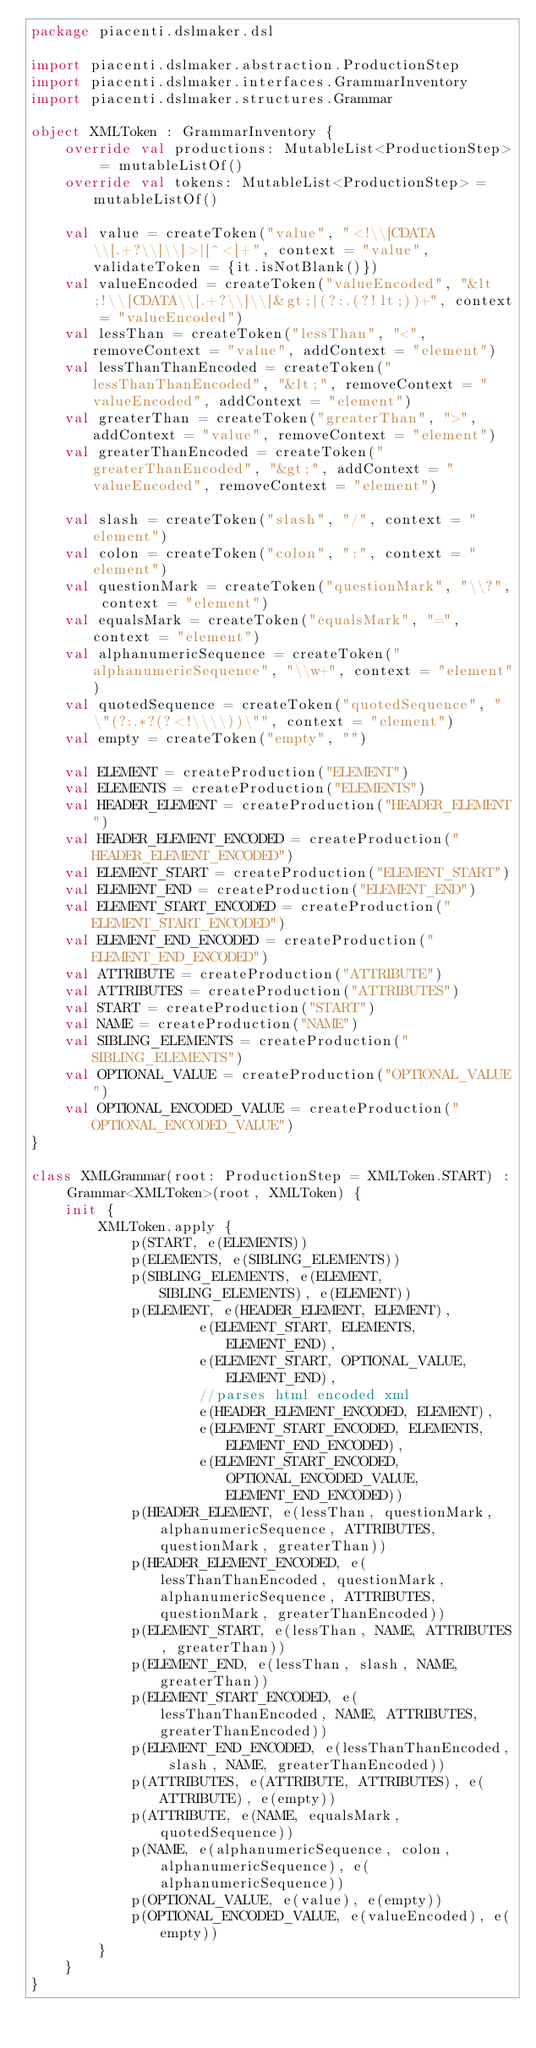Convert code to text. <code><loc_0><loc_0><loc_500><loc_500><_Kotlin_>package piacenti.dslmaker.dsl

import piacenti.dslmaker.abstraction.ProductionStep
import piacenti.dslmaker.interfaces.GrammarInventory
import piacenti.dslmaker.structures.Grammar

object XMLToken : GrammarInventory {
    override val productions: MutableList<ProductionStep> = mutableListOf()
    override val tokens: MutableList<ProductionStep> = mutableListOf()

    val value = createToken("value", "<!\\[CDATA\\[.+?\\]\\]>|[^<]+", context = "value", validateToken = {it.isNotBlank()})
    val valueEncoded = createToken("valueEncoded", "&lt;!\\[CDATA\\[.+?\\]\\]&gt;|(?:.(?!lt;))+", context = "valueEncoded")
    val lessThan = createToken("lessThan", "<", removeContext = "value", addContext = "element")
    val lessThanThanEncoded = createToken("lessThanThanEncoded", "&lt;", removeContext = "valueEncoded", addContext = "element")
    val greaterThan = createToken("greaterThan", ">", addContext = "value", removeContext = "element")
    val greaterThanEncoded = createToken("greaterThanEncoded", "&gt;", addContext = "valueEncoded", removeContext = "element")

    val slash = createToken("slash", "/", context = "element")
    val colon = createToken("colon", ":", context = "element")
    val questionMark = createToken("questionMark", "\\?", context = "element")
    val equalsMark = createToken("equalsMark", "=", context = "element")
    val alphanumericSequence = createToken("alphanumericSequence", "\\w+", context = "element")
    val quotedSequence = createToken("quotedSequence", "\"(?:.*?(?<!\\\\))\"", context = "element")
    val empty = createToken("empty", "")

    val ELEMENT = createProduction("ELEMENT")
    val ELEMENTS = createProduction("ELEMENTS")
    val HEADER_ELEMENT = createProduction("HEADER_ELEMENT")
    val HEADER_ELEMENT_ENCODED = createProduction("HEADER_ELEMENT_ENCODED")
    val ELEMENT_START = createProduction("ELEMENT_START")
    val ELEMENT_END = createProduction("ELEMENT_END")
    val ELEMENT_START_ENCODED = createProduction("ELEMENT_START_ENCODED")
    val ELEMENT_END_ENCODED = createProduction("ELEMENT_END_ENCODED")
    val ATTRIBUTE = createProduction("ATTRIBUTE")
    val ATTRIBUTES = createProduction("ATTRIBUTES")
    val START = createProduction("START")
    val NAME = createProduction("NAME")
    val SIBLING_ELEMENTS = createProduction("SIBLING_ELEMENTS")
    val OPTIONAL_VALUE = createProduction("OPTIONAL_VALUE")
    val OPTIONAL_ENCODED_VALUE = createProduction("OPTIONAL_ENCODED_VALUE")
}

class XMLGrammar(root: ProductionStep = XMLToken.START) : Grammar<XMLToken>(root, XMLToken) {
    init {
        XMLToken.apply {
            p(START, e(ELEMENTS))
            p(ELEMENTS, e(SIBLING_ELEMENTS))
            p(SIBLING_ELEMENTS, e(ELEMENT, SIBLING_ELEMENTS), e(ELEMENT))
            p(ELEMENT, e(HEADER_ELEMENT, ELEMENT),
                    e(ELEMENT_START, ELEMENTS, ELEMENT_END),
                    e(ELEMENT_START, OPTIONAL_VALUE, ELEMENT_END),
                    //parses html encoded xml
                    e(HEADER_ELEMENT_ENCODED, ELEMENT),
                    e(ELEMENT_START_ENCODED, ELEMENTS, ELEMENT_END_ENCODED),
                    e(ELEMENT_START_ENCODED, OPTIONAL_ENCODED_VALUE, ELEMENT_END_ENCODED))
            p(HEADER_ELEMENT, e(lessThan, questionMark, alphanumericSequence, ATTRIBUTES, questionMark, greaterThan))
            p(HEADER_ELEMENT_ENCODED, e(lessThanThanEncoded, questionMark, alphanumericSequence, ATTRIBUTES, questionMark, greaterThanEncoded))
            p(ELEMENT_START, e(lessThan, NAME, ATTRIBUTES, greaterThan))
            p(ELEMENT_END, e(lessThan, slash, NAME, greaterThan))
            p(ELEMENT_START_ENCODED, e(lessThanThanEncoded, NAME, ATTRIBUTES, greaterThanEncoded))
            p(ELEMENT_END_ENCODED, e(lessThanThanEncoded, slash, NAME, greaterThanEncoded))
            p(ATTRIBUTES, e(ATTRIBUTE, ATTRIBUTES), e(ATTRIBUTE), e(empty))
            p(ATTRIBUTE, e(NAME, equalsMark, quotedSequence))
            p(NAME, e(alphanumericSequence, colon, alphanumericSequence), e(alphanumericSequence))
            p(OPTIONAL_VALUE, e(value), e(empty))
            p(OPTIONAL_ENCODED_VALUE, e(valueEncoded), e(empty))
        }
    }
}</code> 